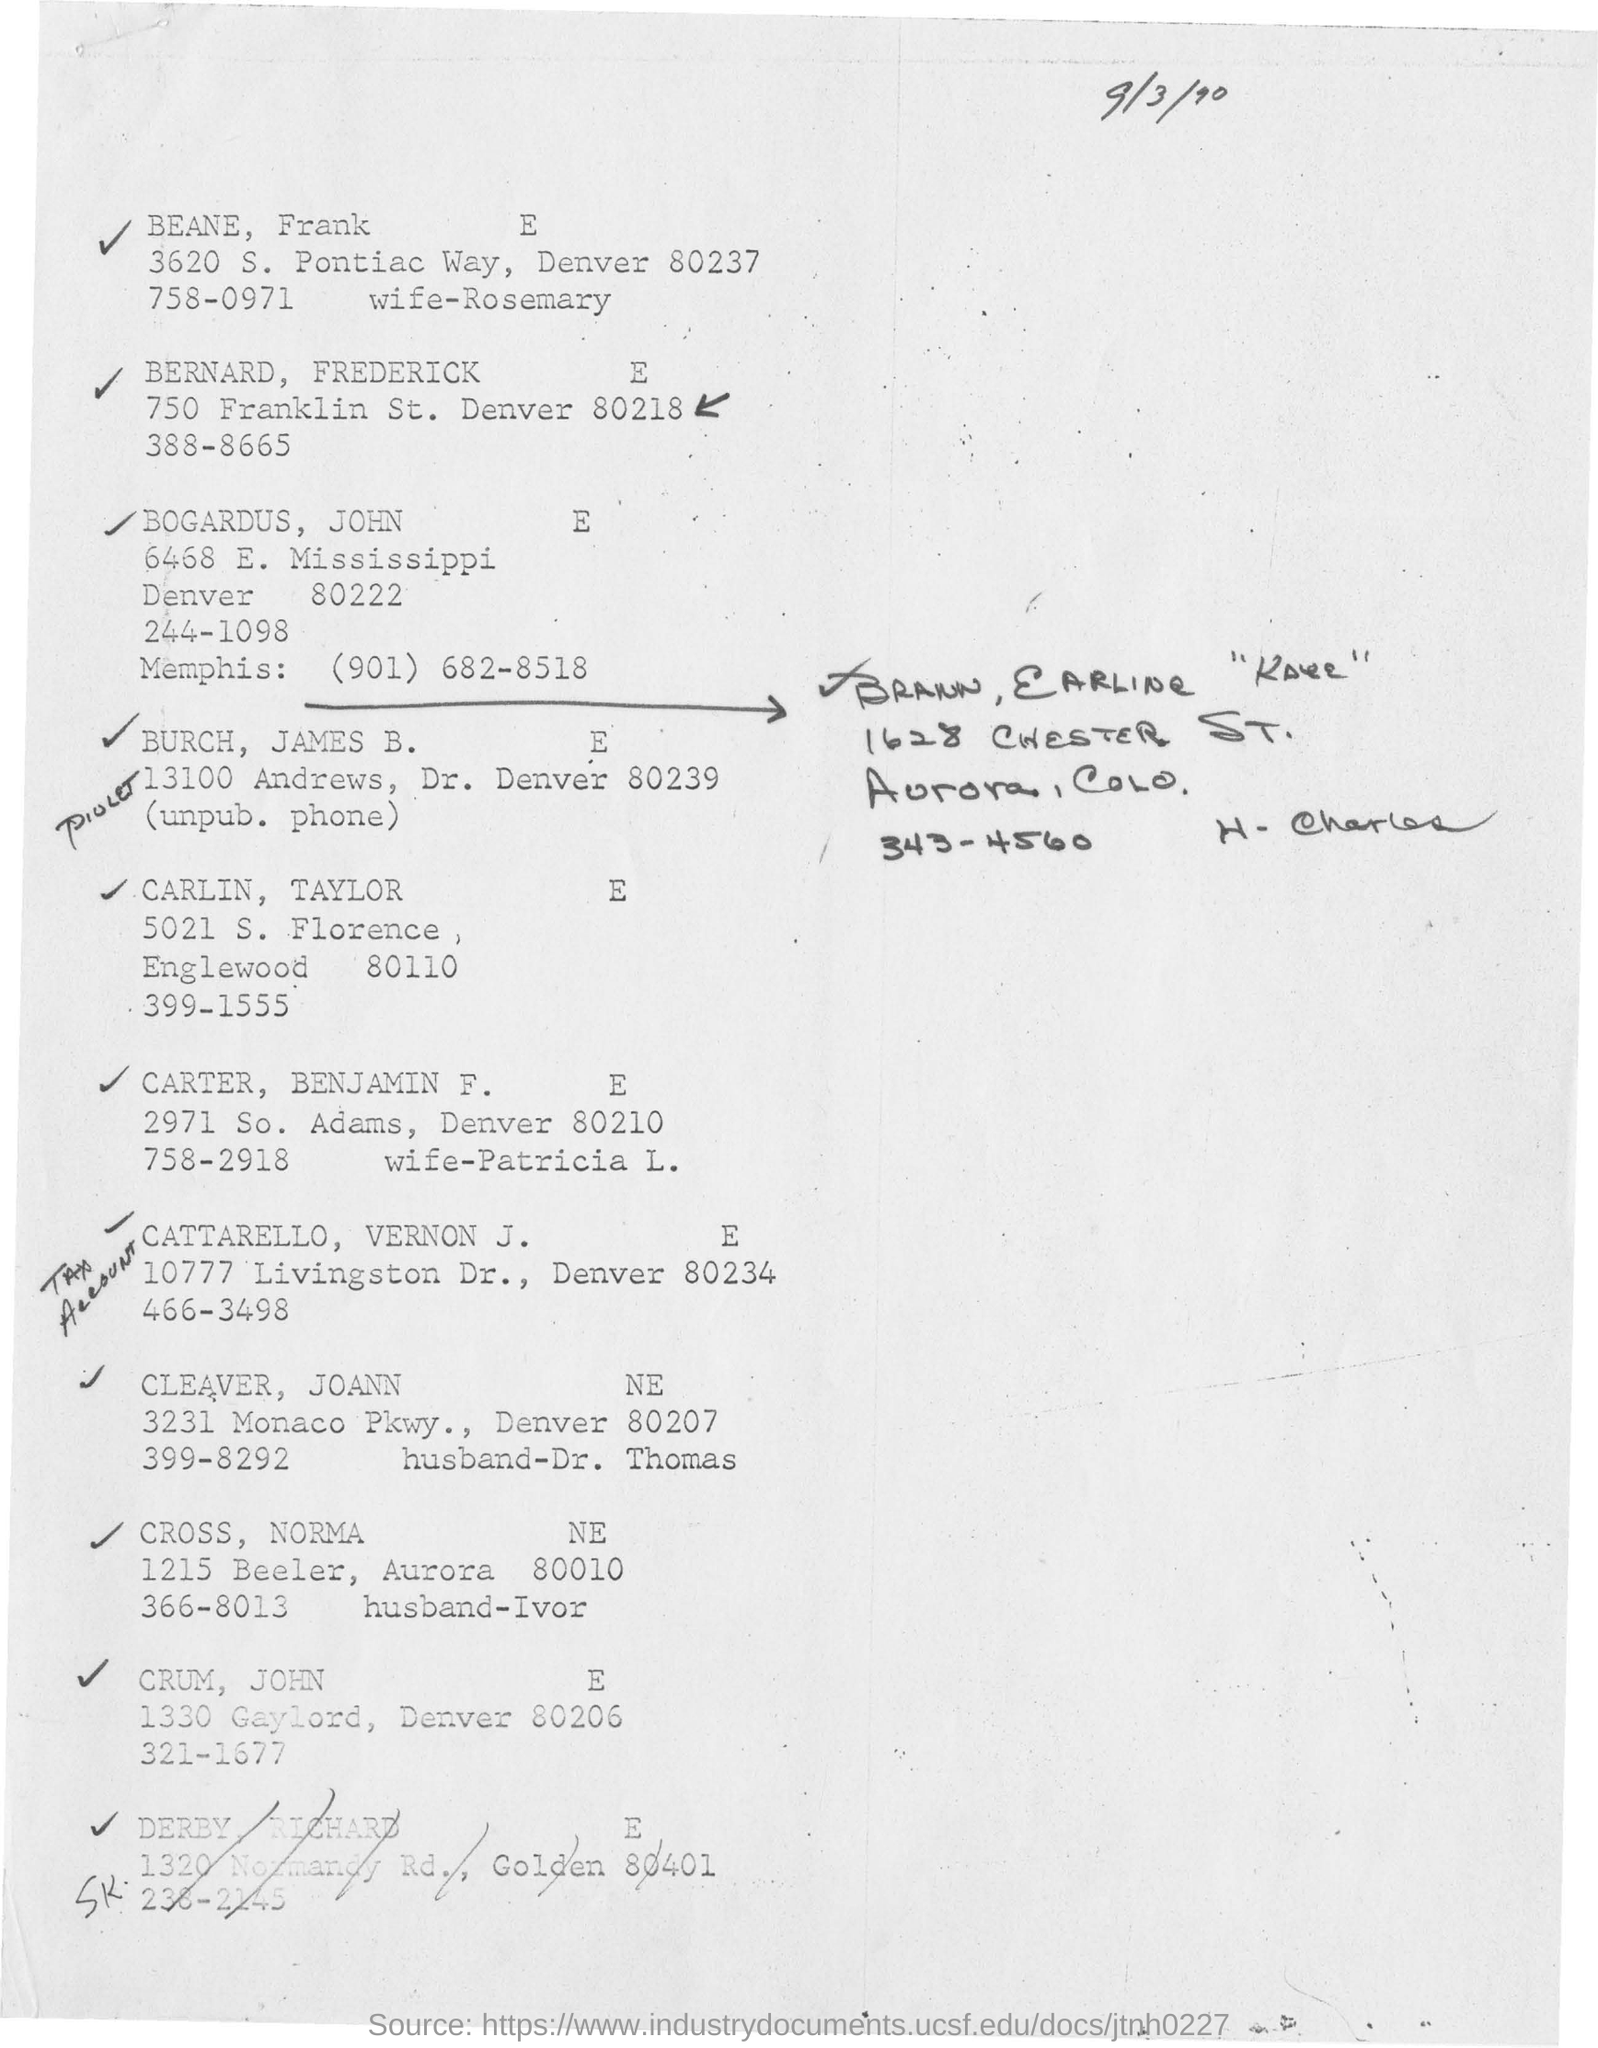What is the date mentioned in this document?
Ensure brevity in your answer.  9/3/90. 